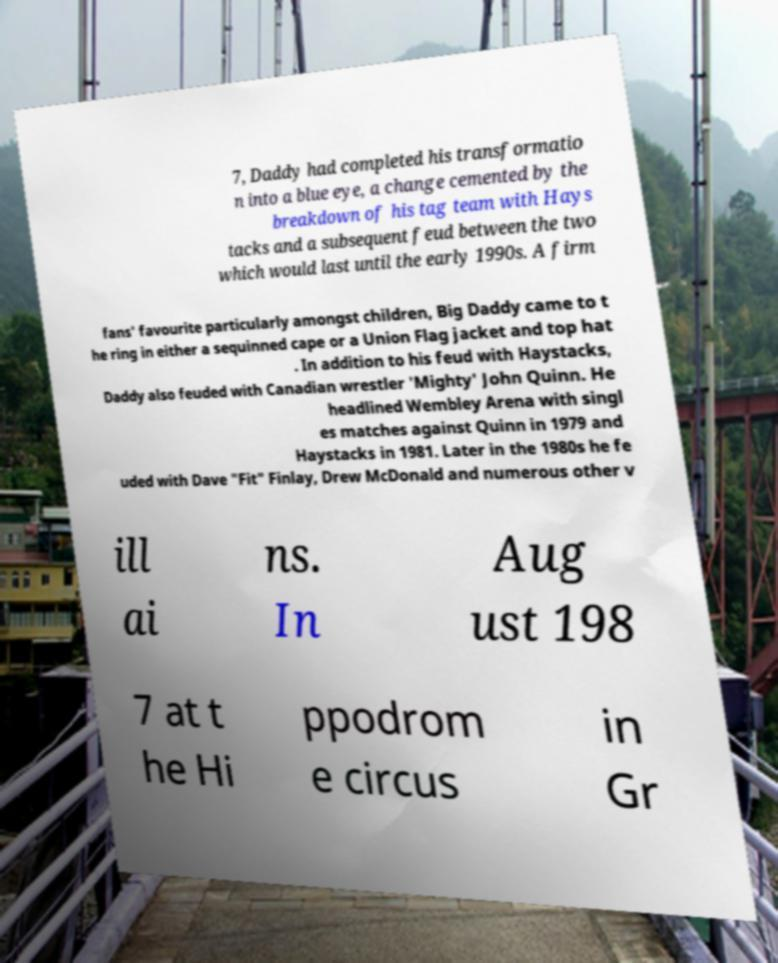What messages or text are displayed in this image? I need them in a readable, typed format. 7, Daddy had completed his transformatio n into a blue eye, a change cemented by the breakdown of his tag team with Hays tacks and a subsequent feud between the two which would last until the early 1990s. A firm fans' favourite particularly amongst children, Big Daddy came to t he ring in either a sequinned cape or a Union Flag jacket and top hat . In addition to his feud with Haystacks, Daddy also feuded with Canadian wrestler 'Mighty' John Quinn. He headlined Wembley Arena with singl es matches against Quinn in 1979 and Haystacks in 1981. Later in the 1980s he fe uded with Dave "Fit" Finlay, Drew McDonald and numerous other v ill ai ns. In Aug ust 198 7 at t he Hi ppodrom e circus in Gr 